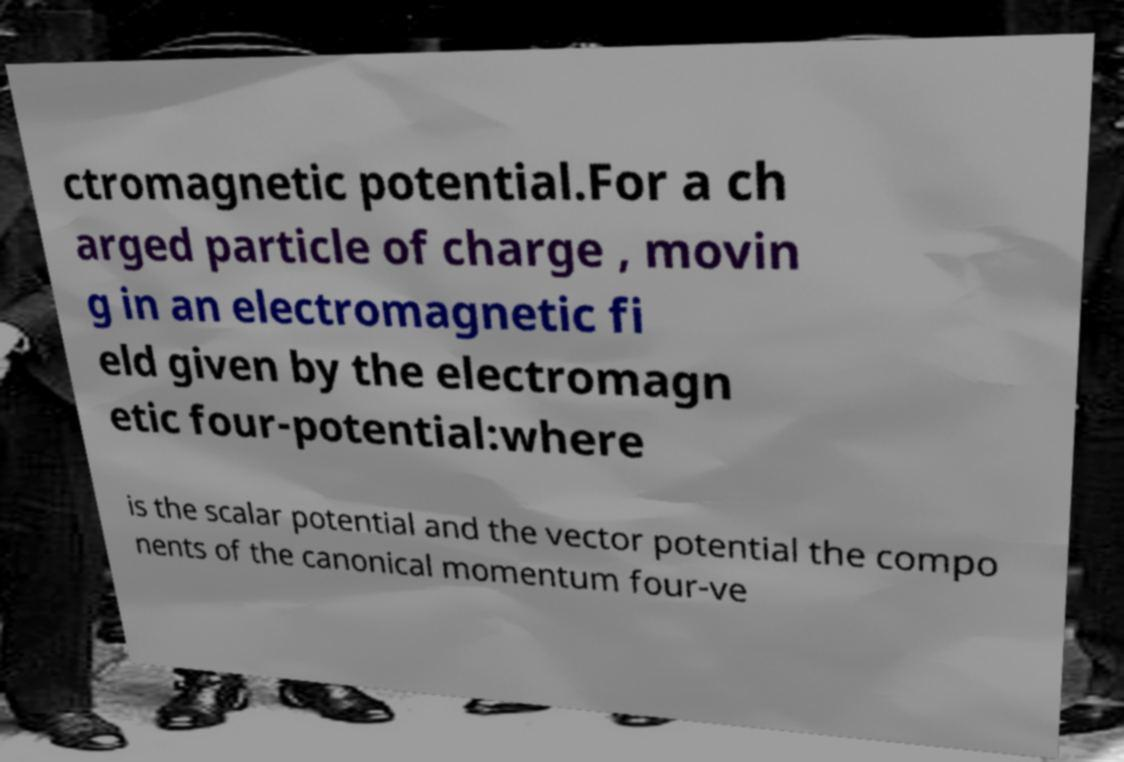For documentation purposes, I need the text within this image transcribed. Could you provide that? ctromagnetic potential.For a ch arged particle of charge , movin g in an electromagnetic fi eld given by the electromagn etic four-potential:where is the scalar potential and the vector potential the compo nents of the canonical momentum four-ve 